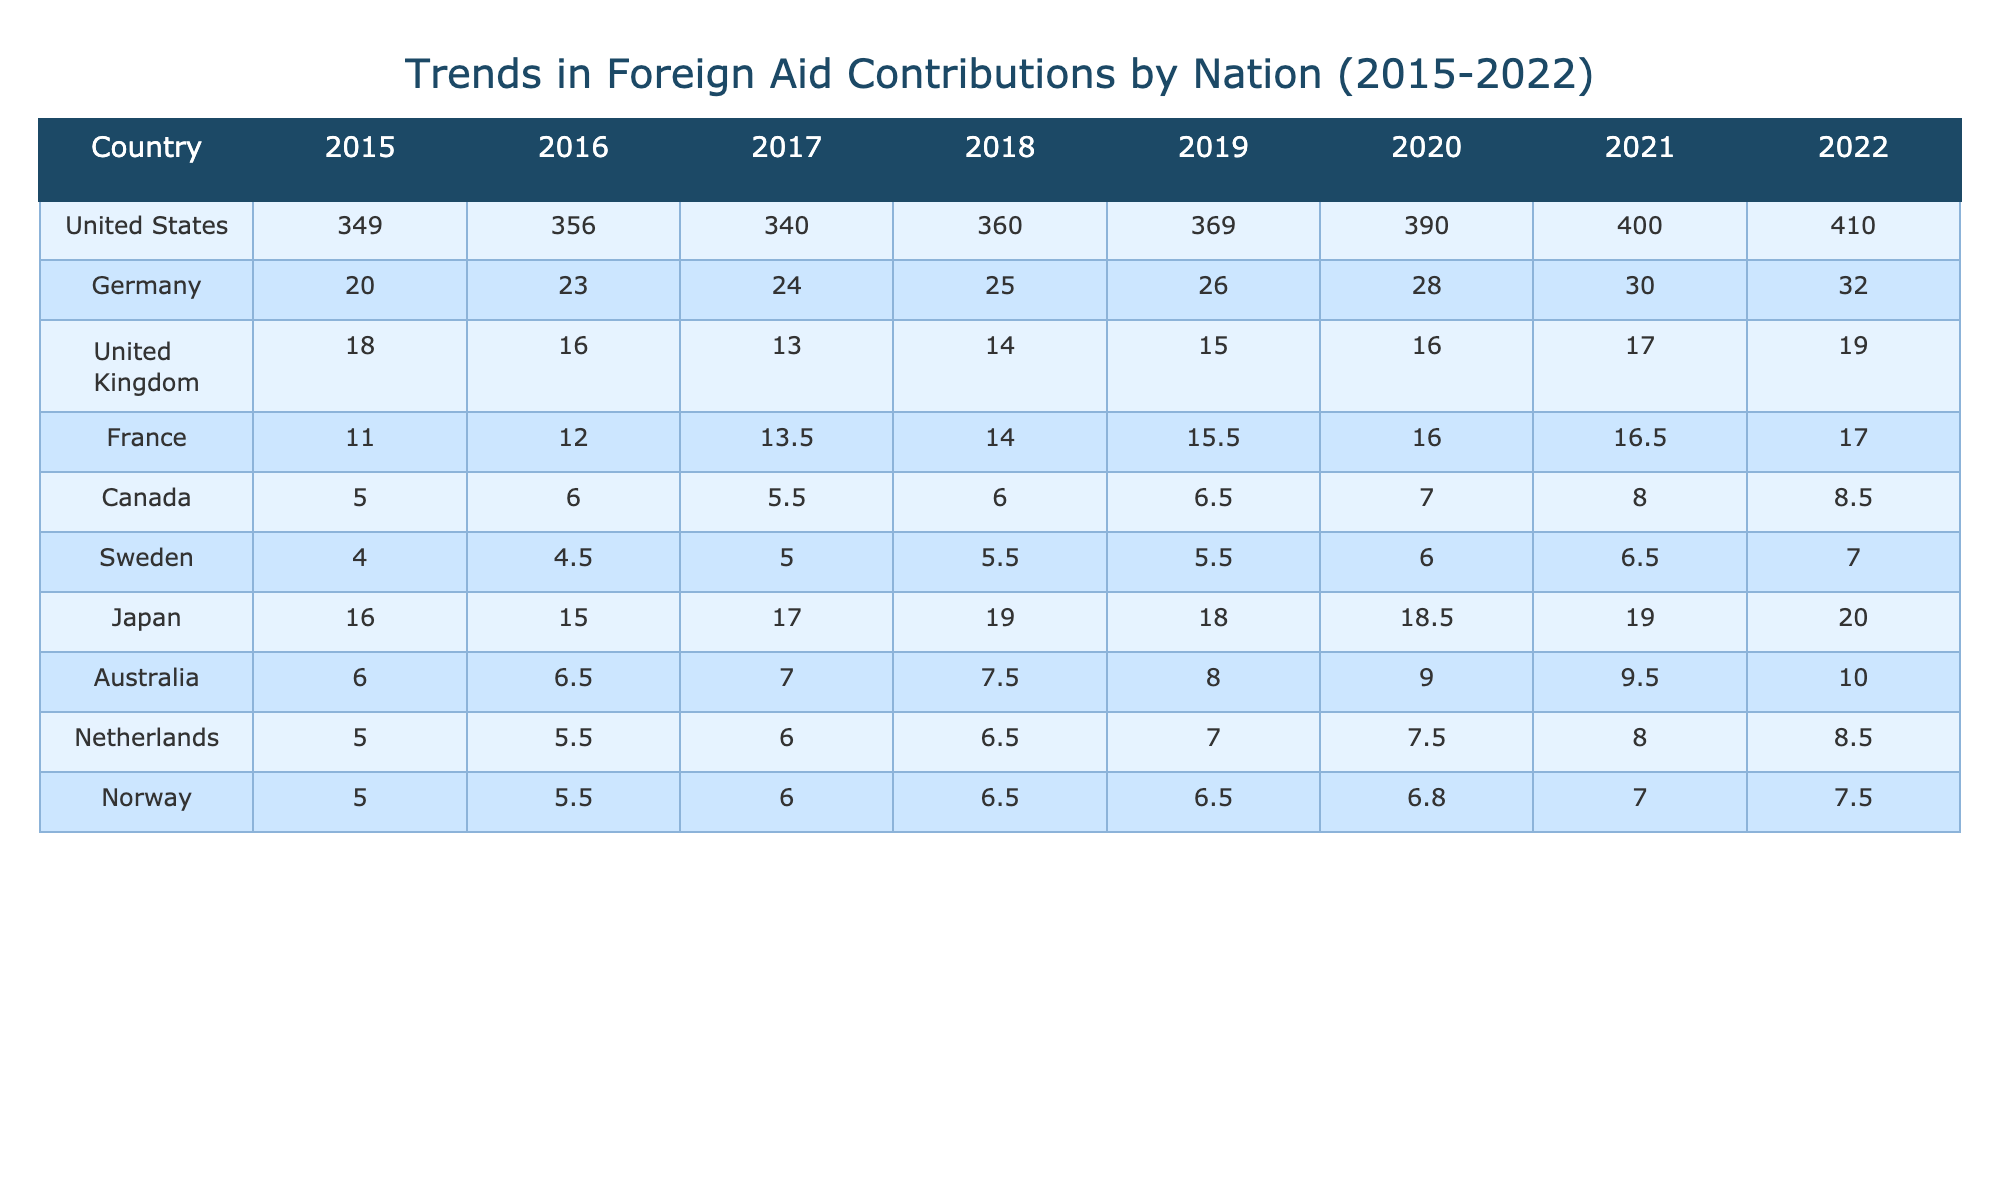What was the total foreign aid contribution from the United States in 2022? The table indicates that the foreign aid contribution from the United States in 2022 is 410.0.
Answer: 410.0 Which country had the highest contribution in 2019? Reviewing the table, the contributions for 2019 are: United States - 369.0, Germany - 26.0, United Kingdom - 15.0, and others. The United States had the highest contribution with 369.0.
Answer: United States What is the average foreign aid contribution from Canada over the years 2015 to 2022? The contributions from Canada are: 5.0, 6.0, 5.5, 6.0, 6.5, 7.0, 8.0, 8.5. Summing these contributions gives 5.0 + 6.0 + 5.5 + 6.0 + 6.5 + 7.0 + 8.0 + 8.5 = 54.5. There are 8 years, so the average is 54.5 / 8 = 6.8125, which rounds to 6.81.
Answer: 6.81 Did Japan's foreign aid contribution increase every year from 2015 to 2022? Checking the contributions from Japan: 16.0 (2015), 15.0 (2016), 17.0 (2017), 19.0 (2018), 18.0 (2019), 18.5 (2020), 19.0 (2021), and 20.0 (2022). In 2016 and 2019, the contribution decreased, indicating that it did not increase every year.
Answer: No What is the overall trend in foreign aid contributions from Germany from 2015 to 2022? The contributions from Germany are: 20.0, 23.0, 24.0, 25.0, 26.0, 28.0, 30.0, 32.0. There is a consistent increase each year, starting from 20.0 in 2015 up to 32.0 in 2022, demonstrating a clear upward trend in contributions.
Answer: Increasing What was the difference in foreign aid contributions from the United Kingdom between 2015 and 2022? The contribution from the United Kingdom in 2015 was 18.0, and in 2022 it was 19.0. The difference is 19.0 - 18.0 = 1.0.
Answer: 1.0 Which country had the lowest foreign aid contribution in 2016? In the table for 2016, the contributions from each country are: United States - 356.0, Germany - 23.0, United Kingdom - 16.0, Canada - 6.0, Sweden - 4.5, Japan - 15.0, Australia - 6.5, Netherlands - 5.5, and Norway - 5.5. Sweden had the lowest contribution at 4.5.
Answer: Sweden How much did Australia contribute in total from 2015 to 2022? The contributions from Australia during these years are: 6.0, 6.5, 7.0, 7.5, 8.0, 9.0, 9.5, 10.0. Adding these amounts gives 6.0 + 6.5 + 7.0 + 7.5 + 8.0 + 9.0 + 9.5 + 10.0 = 63.5.
Answer: 63.5 